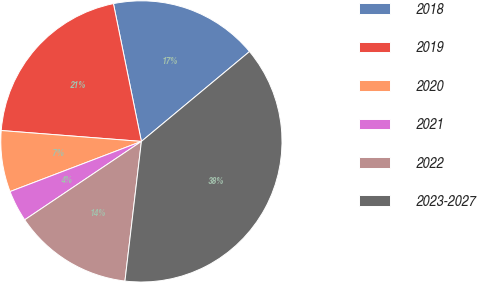Convert chart. <chart><loc_0><loc_0><loc_500><loc_500><pie_chart><fcel>2018<fcel>2019<fcel>2020<fcel>2021<fcel>2022<fcel>2023-2027<nl><fcel>17.15%<fcel>20.58%<fcel>7.04%<fcel>3.61%<fcel>13.72%<fcel>37.91%<nl></chart> 